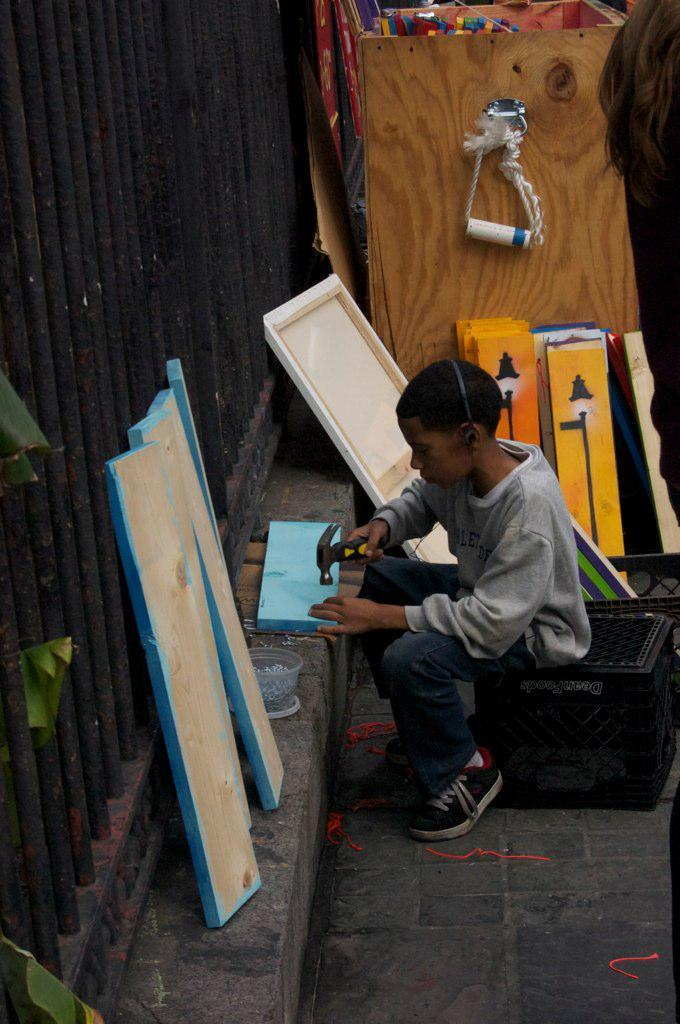What is the person in the image doing? The person is sitting on a platform and holding a hammer. What can be seen in the background of the image? There is a fence and wooden planks in the background of the image. What type of furniture is visible in the image? There is no furniture visible in the image. What time of day is it in the image? The time of day cannot be determined from the image. 